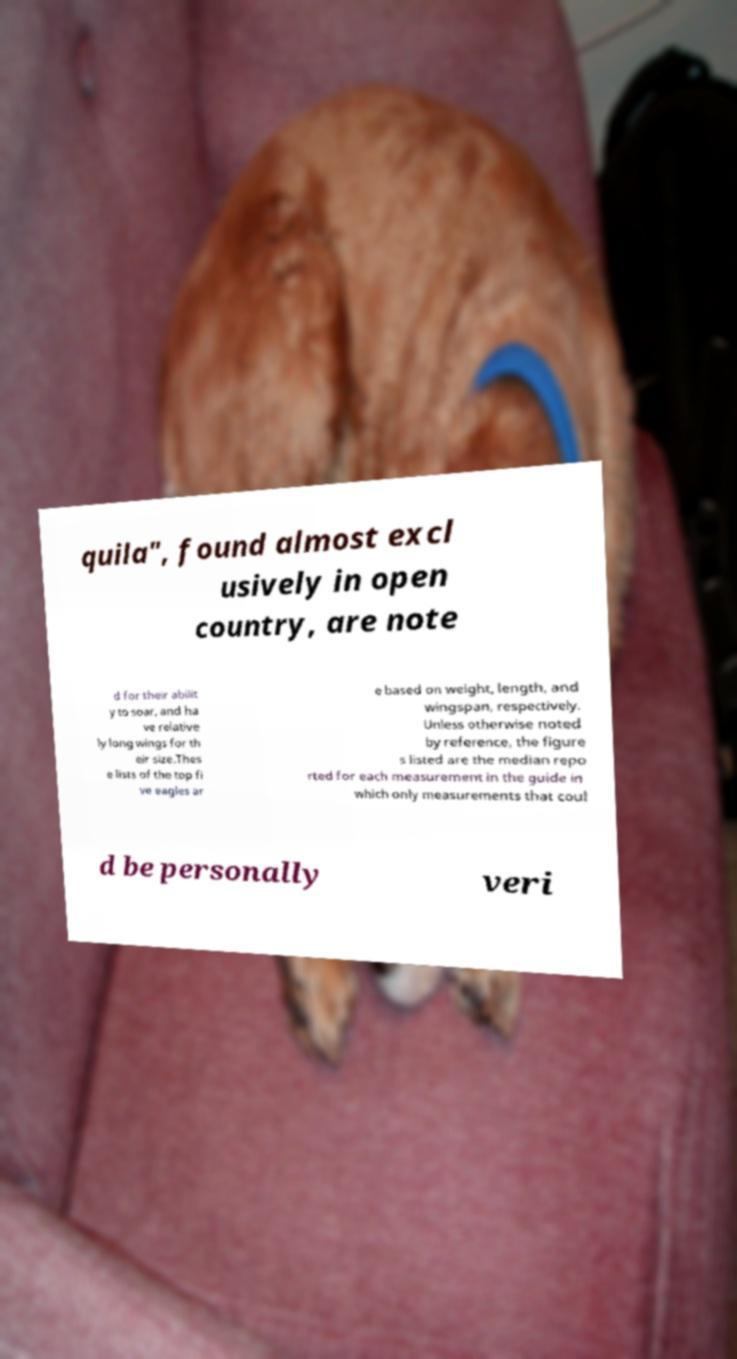Could you extract and type out the text from this image? quila", found almost excl usively in open country, are note d for their abilit y to soar, and ha ve relative ly long wings for th eir size.Thes e lists of the top fi ve eagles ar e based on weight, length, and wingspan, respectively. Unless otherwise noted by reference, the figure s listed are the median repo rted for each measurement in the guide in which only measurements that coul d be personally veri 